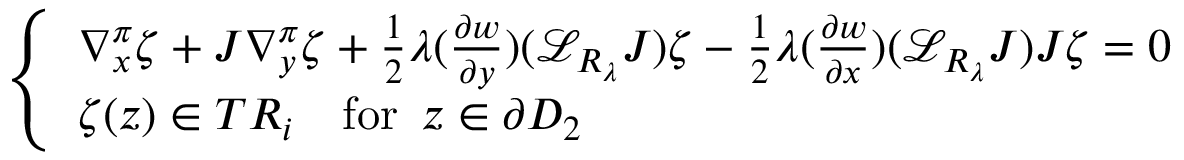Convert formula to latex. <formula><loc_0><loc_0><loc_500><loc_500>\left \{ \begin{array} { l l } { \nabla _ { x } ^ { \pi } \zeta + J \nabla _ { y } ^ { \pi } \zeta + \frac { 1 } { 2 } \lambda ( \frac { \partial w } { \partial y } ) ( { \mathcal { L } } _ { R _ { \lambda } } J ) \zeta - \frac { 1 } { 2 } \lambda ( \frac { \partial w } { \partial x } ) ( { \mathcal { L } } _ { R _ { \lambda } } J ) J \zeta = 0 } \\ { \zeta ( z ) \in T R _ { i } \quad f o r \, z \in \partial D _ { 2 } } \end{array}</formula> 